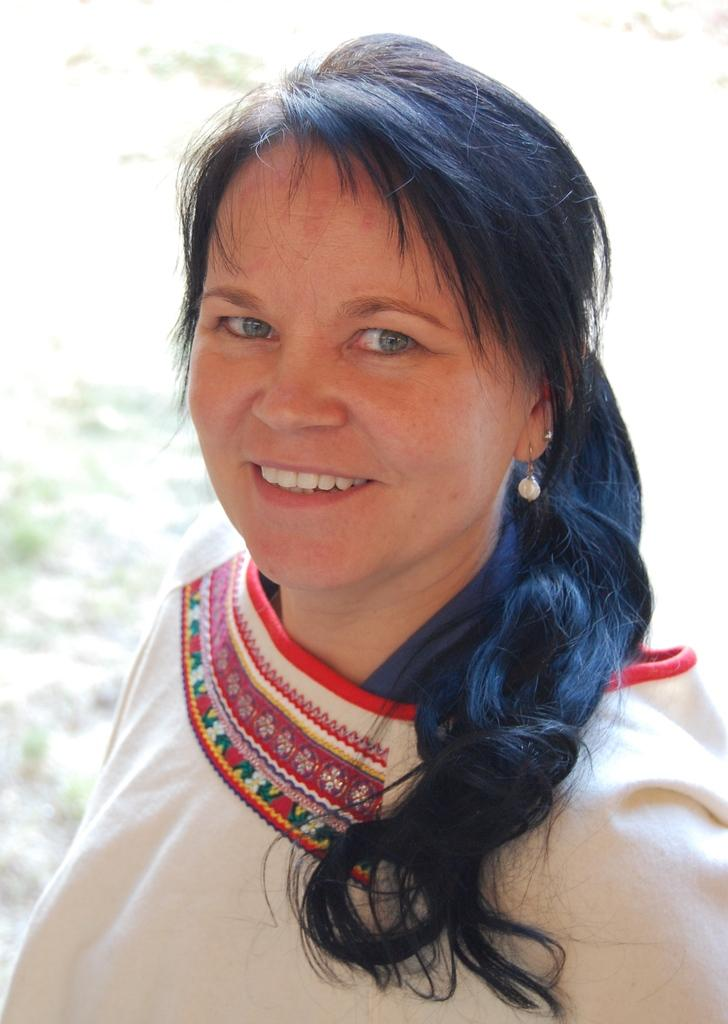Who is present in the image? There is a woman in the image. What is the woman's expression? The woman is smiling. Can you describe the background of the image? The background of the image is not clear. What type of request is the woman making in the image? There is no indication in the image that the woman is making any request. 